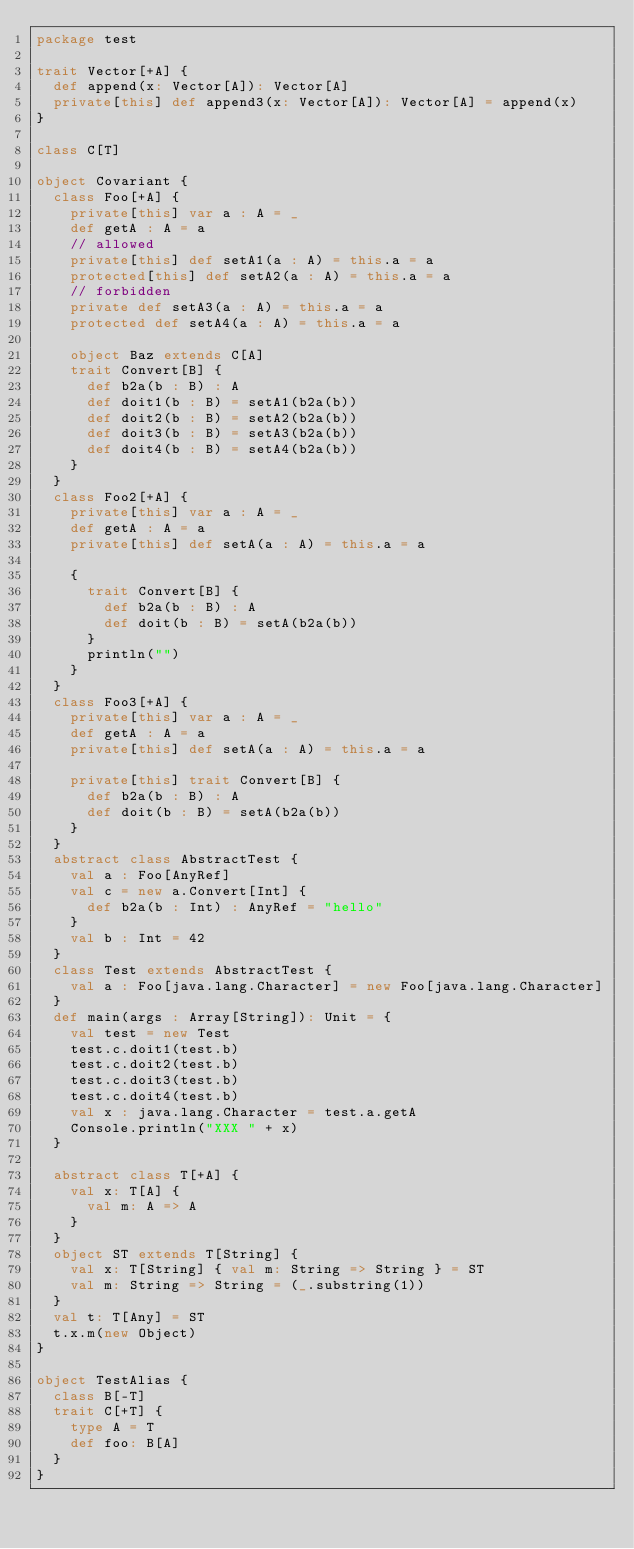<code> <loc_0><loc_0><loc_500><loc_500><_Scala_>package test

trait Vector[+A] {
  def append(x: Vector[A]): Vector[A]
  private[this] def append3(x: Vector[A]): Vector[A] = append(x)
}

class C[T]

object Covariant {
  class Foo[+A] {
    private[this] var a : A = _
    def getA : A = a
    // allowed
    private[this] def setA1(a : A) = this.a = a
    protected[this] def setA2(a : A) = this.a = a
    // forbidden
    private def setA3(a : A) = this.a = a
    protected def setA4(a : A) = this.a = a

    object Baz extends C[A]
    trait Convert[B] {
      def b2a(b : B) : A
      def doit1(b : B) = setA1(b2a(b))
      def doit2(b : B) = setA2(b2a(b))
      def doit3(b : B) = setA3(b2a(b))
      def doit4(b : B) = setA4(b2a(b))
    }
  }
  class Foo2[+A] {
    private[this] var a : A = _
    def getA : A = a
    private[this] def setA(a : A) = this.a = a

    {
      trait Convert[B] {
        def b2a(b : B) : A
        def doit(b : B) = setA(b2a(b))
      }
      println("")
    }
  }
  class Foo3[+A] {
    private[this] var a : A = _
    def getA : A = a
    private[this] def setA(a : A) = this.a = a

    private[this] trait Convert[B] {
      def b2a(b : B) : A
      def doit(b : B) = setA(b2a(b))
    }
  }
  abstract class AbstractTest {
    val a : Foo[AnyRef]
    val c = new a.Convert[Int] {
      def b2a(b : Int) : AnyRef = "hello"
    }
    val b : Int = 42
  }
  class Test extends AbstractTest {
    val a : Foo[java.lang.Character] = new Foo[java.lang.Character]
  }
  def main(args : Array[String]): Unit = {
    val test = new Test
    test.c.doit1(test.b)
    test.c.doit2(test.b)
    test.c.doit3(test.b)
    test.c.doit4(test.b)
    val x : java.lang.Character = test.a.getA
    Console.println("XXX " + x)
  }

  abstract class T[+A] {
    val x: T[A] {
      val m: A => A
    }
  }
  object ST extends T[String] {
    val x: T[String] { val m: String => String } = ST
    val m: String => String = (_.substring(1))
  }
  val t: T[Any] = ST
  t.x.m(new Object)
}

object TestAlias {
  class B[-T]
  trait C[+T] {
    type A = T
    def foo: B[A]
  }
}
</code> 